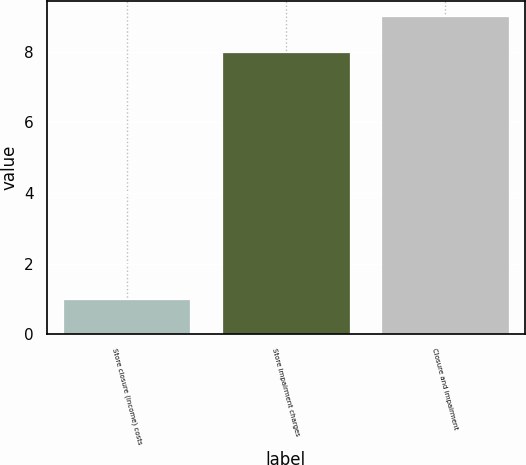Convert chart to OTSL. <chart><loc_0><loc_0><loc_500><loc_500><bar_chart><fcel>Store closure (income) costs<fcel>Store impairment charges<fcel>Closure and impairment<nl><fcel>1<fcel>8<fcel>9<nl></chart> 